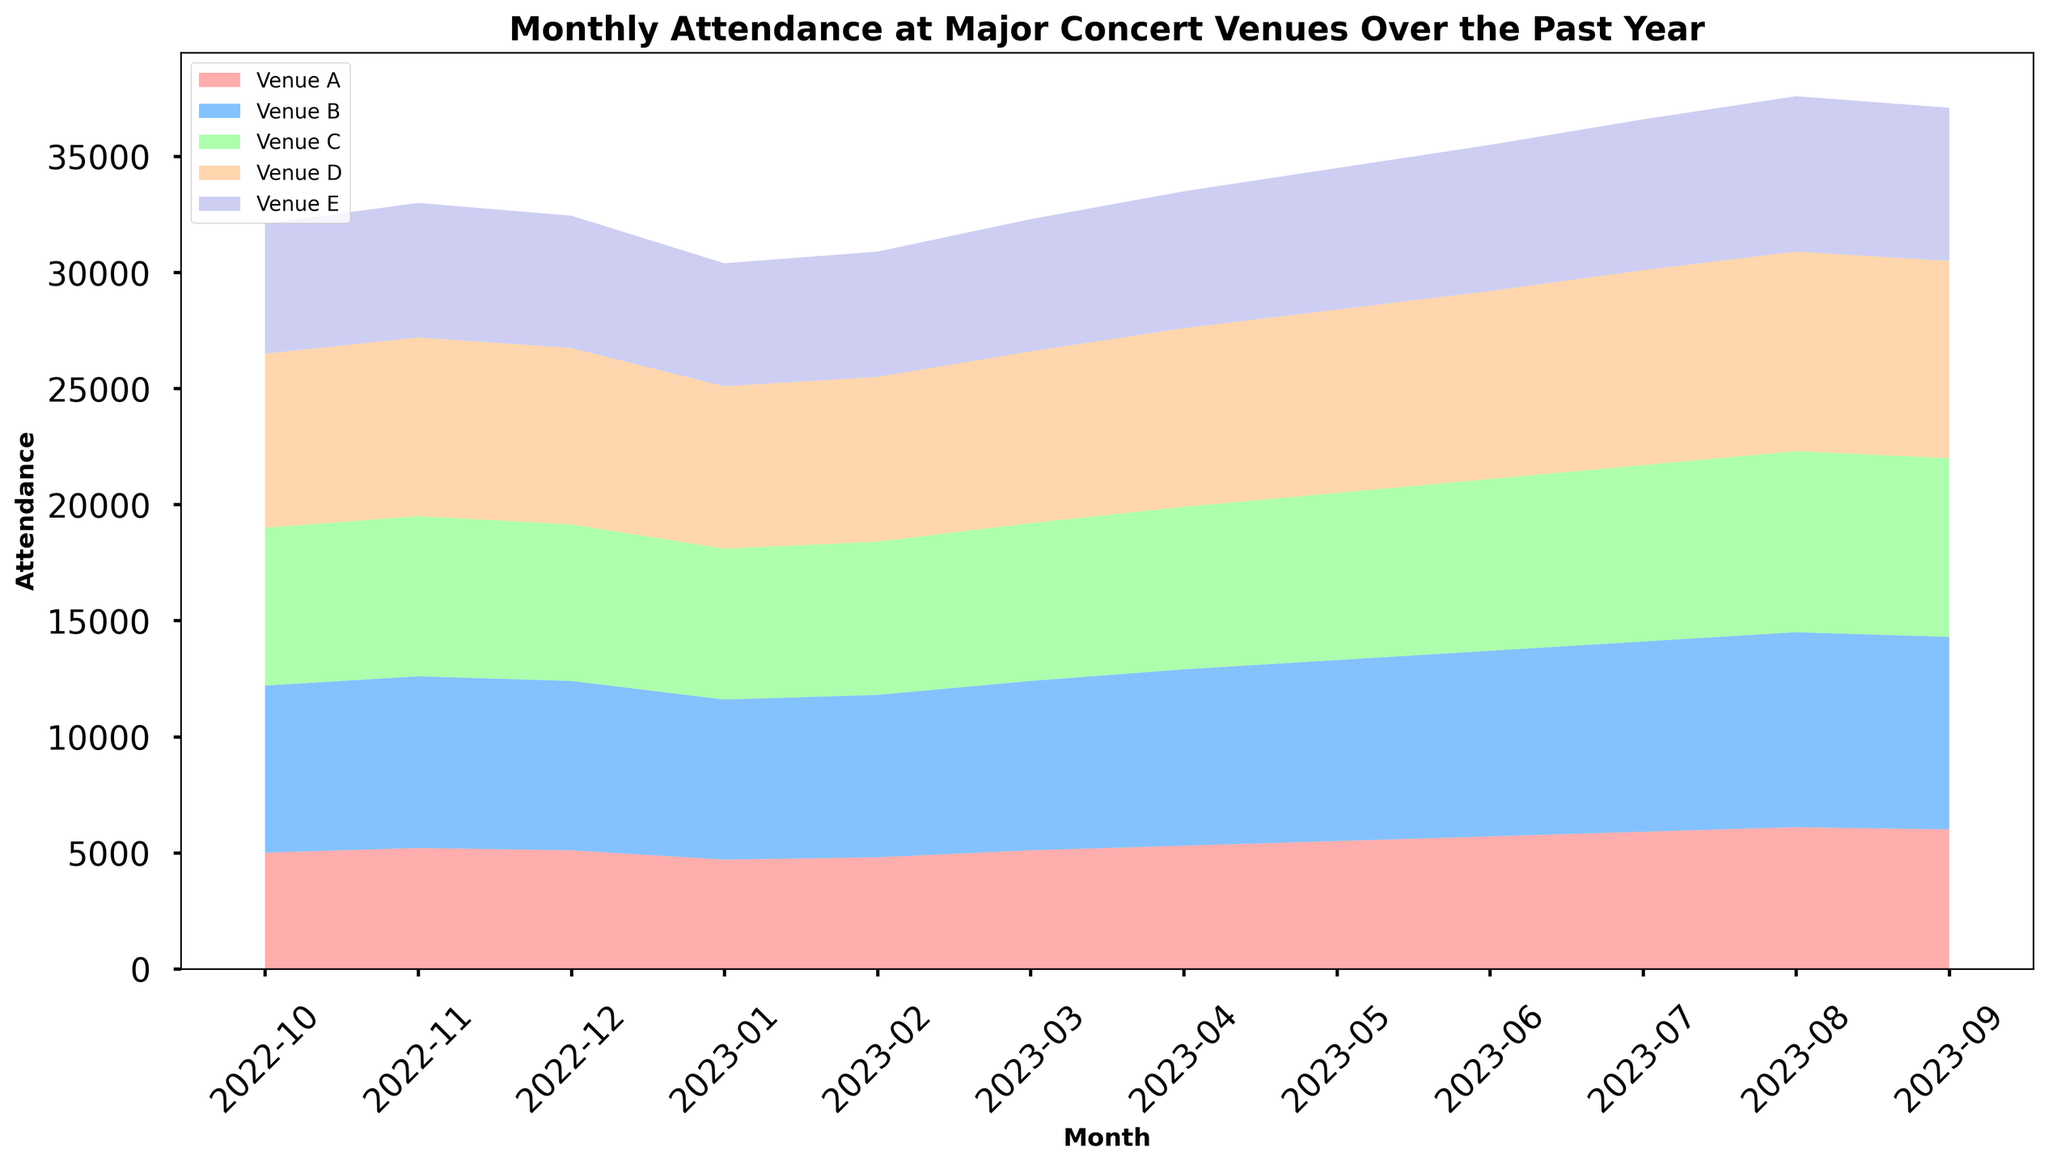Which venue had the highest attendance in August 2023? Look at the attendance values for each venue in August 2023 and see which one is the highest. Venue E has the highest attendance in August 2023.
Answer: Venue E How many months did Venue B have a higher attendance than Venue C? Compare the attendance values for Venue B and Venue C month by month and count how many times Venue B's attendance was higher.
Answer: 12 Which month had the lowest overall attendance across all venues? Sum the attendance across all venues for each month and find which month has the smallest sum. January 2023 has the lowest overall attendance.
Answer: January 2023 What is the total attendance in June 2023 across all venues? Sum the attendance values for all venues in June 2023: 5700 + 8000 + 7400 + 8100 + 6300 = 35500.
Answer: 35500 Has the attendance at Venue D ever decreased from one month to the next? Look at Venue D's attendance values and see if there's any month where the number is smaller than the previous month. In January 2023, the attendance at Venue D decreased from 7600 to 7000.
Answer: Yes What is the average monthly attendance for Venue A over the past year? Sum all the monthly attandance values for Venue A and divide by 12: (5000 + 5200 + 5100 + 4700 + 4800 + 5100 + 5300 + 5500 + 5700 + 5900 + 6100 + 6000)/12 = 5350.
Answer: 5350 Which venue shows the least variance in attendance over the year? Calculate the variance in attendance for each venue and find which one is the smallest. Variance for Venue A = 124,020.833, Venue B = 584,833.33, Venue C = 185,650, Venue D = 482,166.67, Venue E = 129,650. Therefore, Venue A has the least variance.
Answer: Venue A In which months did Venue C have more attendance than Venue E? Compare Venue C's and Venue E's attendance month by month and list the months where Venue C's attendance was higher. Venue C had more attendance in October 2022, November 2022, December 2022, January 2023, February 2023, March 2023, and September 2023.
Answer: October 2022, November 2022, December 2022, January 2023, February 2023, March 2023, September 2023 